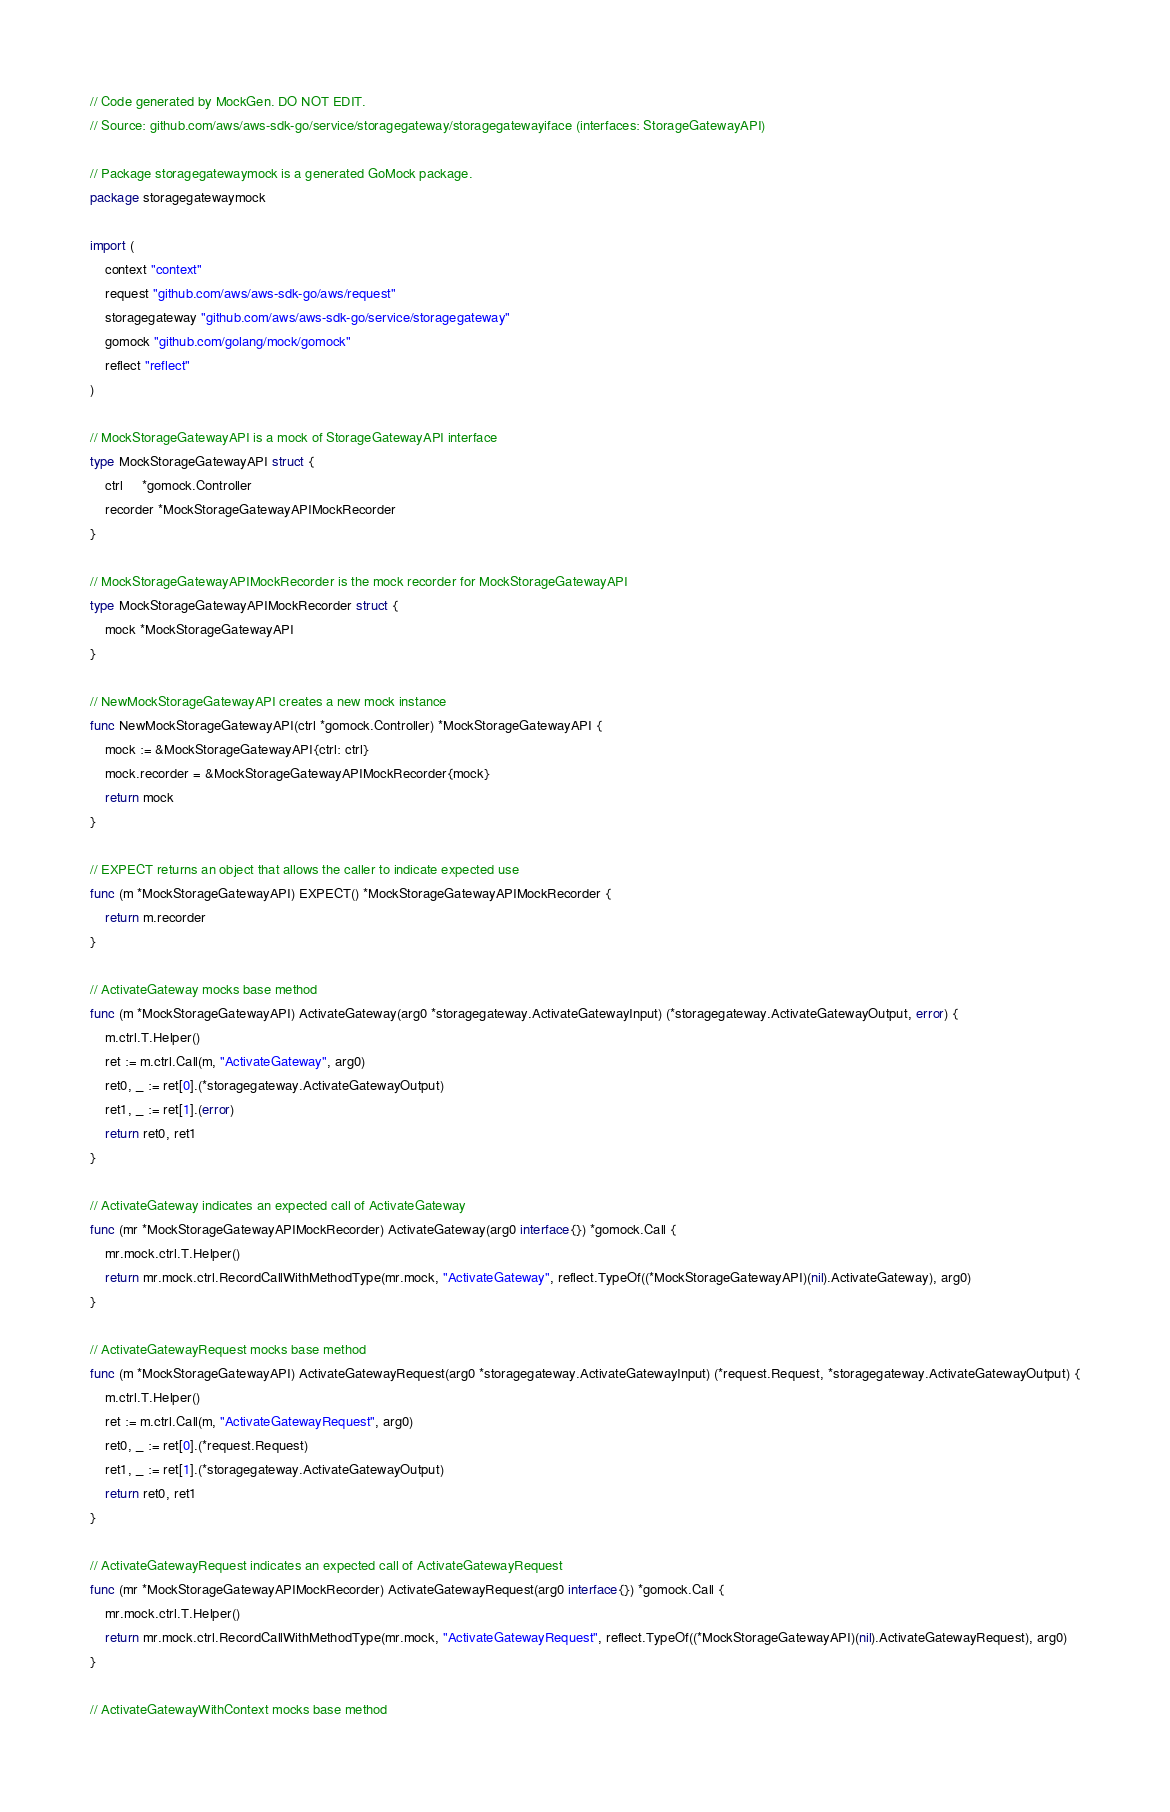<code> <loc_0><loc_0><loc_500><loc_500><_Go_>// Code generated by MockGen. DO NOT EDIT.
// Source: github.com/aws/aws-sdk-go/service/storagegateway/storagegatewayiface (interfaces: StorageGatewayAPI)

// Package storagegatewaymock is a generated GoMock package.
package storagegatewaymock

import (
	context "context"
	request "github.com/aws/aws-sdk-go/aws/request"
	storagegateway "github.com/aws/aws-sdk-go/service/storagegateway"
	gomock "github.com/golang/mock/gomock"
	reflect "reflect"
)

// MockStorageGatewayAPI is a mock of StorageGatewayAPI interface
type MockStorageGatewayAPI struct {
	ctrl     *gomock.Controller
	recorder *MockStorageGatewayAPIMockRecorder
}

// MockStorageGatewayAPIMockRecorder is the mock recorder for MockStorageGatewayAPI
type MockStorageGatewayAPIMockRecorder struct {
	mock *MockStorageGatewayAPI
}

// NewMockStorageGatewayAPI creates a new mock instance
func NewMockStorageGatewayAPI(ctrl *gomock.Controller) *MockStorageGatewayAPI {
	mock := &MockStorageGatewayAPI{ctrl: ctrl}
	mock.recorder = &MockStorageGatewayAPIMockRecorder{mock}
	return mock
}

// EXPECT returns an object that allows the caller to indicate expected use
func (m *MockStorageGatewayAPI) EXPECT() *MockStorageGatewayAPIMockRecorder {
	return m.recorder
}

// ActivateGateway mocks base method
func (m *MockStorageGatewayAPI) ActivateGateway(arg0 *storagegateway.ActivateGatewayInput) (*storagegateway.ActivateGatewayOutput, error) {
	m.ctrl.T.Helper()
	ret := m.ctrl.Call(m, "ActivateGateway", arg0)
	ret0, _ := ret[0].(*storagegateway.ActivateGatewayOutput)
	ret1, _ := ret[1].(error)
	return ret0, ret1
}

// ActivateGateway indicates an expected call of ActivateGateway
func (mr *MockStorageGatewayAPIMockRecorder) ActivateGateway(arg0 interface{}) *gomock.Call {
	mr.mock.ctrl.T.Helper()
	return mr.mock.ctrl.RecordCallWithMethodType(mr.mock, "ActivateGateway", reflect.TypeOf((*MockStorageGatewayAPI)(nil).ActivateGateway), arg0)
}

// ActivateGatewayRequest mocks base method
func (m *MockStorageGatewayAPI) ActivateGatewayRequest(arg0 *storagegateway.ActivateGatewayInput) (*request.Request, *storagegateway.ActivateGatewayOutput) {
	m.ctrl.T.Helper()
	ret := m.ctrl.Call(m, "ActivateGatewayRequest", arg0)
	ret0, _ := ret[0].(*request.Request)
	ret1, _ := ret[1].(*storagegateway.ActivateGatewayOutput)
	return ret0, ret1
}

// ActivateGatewayRequest indicates an expected call of ActivateGatewayRequest
func (mr *MockStorageGatewayAPIMockRecorder) ActivateGatewayRequest(arg0 interface{}) *gomock.Call {
	mr.mock.ctrl.T.Helper()
	return mr.mock.ctrl.RecordCallWithMethodType(mr.mock, "ActivateGatewayRequest", reflect.TypeOf((*MockStorageGatewayAPI)(nil).ActivateGatewayRequest), arg0)
}

// ActivateGatewayWithContext mocks base method</code> 